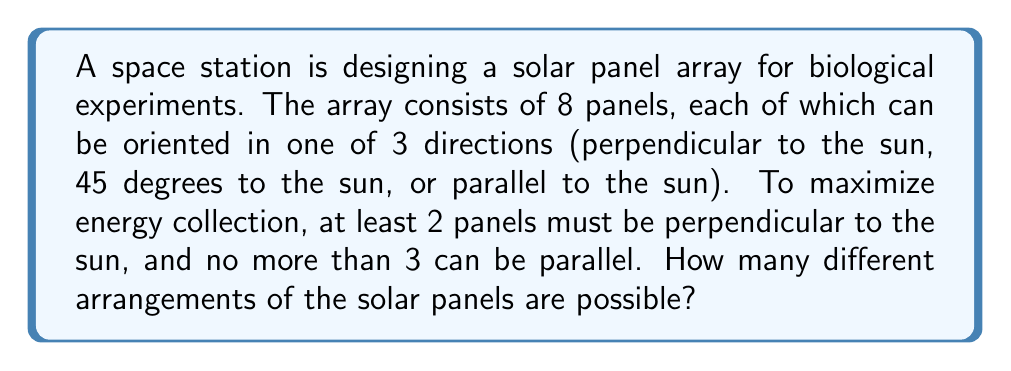Show me your answer to this math problem. Let's approach this step-by-step:

1) We can use the principle of inclusion-exclusion to solve this problem.

2) Let's define our variables:
   $n$ = perpendicular panels
   $m$ = 45-degree panels
   $k$ = parallel panels

3) We know that:
   $n + m + k = 8$ (total panels)
   $n \geq 2$ (at least 2 perpendicular)
   $k \leq 3$ (no more than 3 parallel)

4) We can break this down into cases:

   Case 1: 2 perpendicular panels $(n=2)$
   Case 2: 3 perpendicular panels $(n=3)$
   Case 3: 4 perpendicular panels $(n=4)$
   Case 4: 5 perpendicular panels $(n=5)$
   Case 5: 6 perpendicular panels $(n=6)$

5) For each case, we need to calculate the number of ways to arrange the remaining panels between 45-degree and parallel orientations.

6) Let's use the combination formula: $\dbinom{8}{n} \cdot \dbinom{8-n}{k}$

   Case 1: $\dbinom{8}{2} \cdot (\dbinom{6}{0} + \dbinom{6}{1} + \dbinom{6}{2} + \dbinom{6}{3})$
   Case 2: $\dbinom{8}{3} \cdot (\dbinom{5}{0} + \dbinom{5}{1} + \dbinom{5}{2} + \dbinom{5}{3})$
   Case 3: $\dbinom{8}{4} \cdot (\dbinom{4}{0} + \dbinom{4}{1} + \dbinom{4}{2} + \dbinom{4}{3})$
   Case 4: $\dbinom{8}{5} \cdot (\dbinom{3}{0} + \dbinom{3}{1} + \dbinom{3}{2} + \dbinom{3}{3})$
   Case 5: $\dbinom{8}{6} \cdot (\dbinom{2}{0} + \dbinom{2}{1} + \dbinom{2}{2})$

7) Calculating each case:
   Case 1: $28 \cdot (1 + 6 + 15 + 20) = 28 \cdot 42 = 1176$
   Case 2: $56 \cdot (1 + 5 + 10 + 10) = 56 \cdot 26 = 1456$
   Case 3: $70 \cdot (1 + 4 + 6 + 4) = 70 \cdot 15 = 1050$
   Case 4: $56 \cdot (1 + 3 + 3 + 1) = 56 \cdot 8 = 448$
   Case 5: $28 \cdot (1 + 2 + 1) = 28 \cdot 4 = 112$

8) The total number of arrangements is the sum of all cases:
   $1176 + 1456 + 1050 + 448 + 112 = 4242$
Answer: 4242 